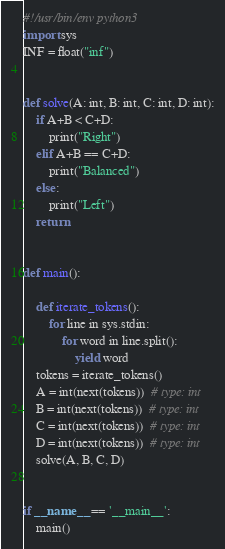Convert code to text. <code><loc_0><loc_0><loc_500><loc_500><_Python_>#!/usr/bin/env python3
import sys
INF = float("inf")


def solve(A: int, B: int, C: int, D: int):
    if A+B < C+D:
        print("Right")
    elif A+B == C+D:
        print("Balanced")
    else:
        print("Left")
    return


def main():

    def iterate_tokens():
        for line in sys.stdin:
            for word in line.split():
                yield word
    tokens = iterate_tokens()
    A = int(next(tokens))  # type: int
    B = int(next(tokens))  # type: int
    C = int(next(tokens))  # type: int
    D = int(next(tokens))  # type: int
    solve(A, B, C, D)


if __name__ == '__main__':
    main()
</code> 